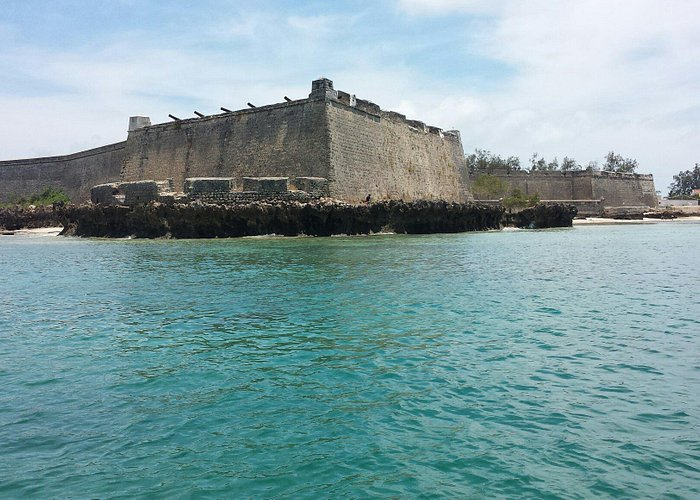What do you see happening in this image? The image showcases the majestic Fort of São Sebastião on Mozambique Island. This grand stone fortress, with its rectangular structure and flat roof, tells a story of a time long past. Perched at the island's edge, it offers a stunning view over the serene turquoise waters of the ocean. Above, the sky is a clear blue with a sprinkling of fluffy clouds, adding to the peaceful panorama. Despite its grandeur, the fort bears the marks of history; its stone walls show signs of deterioration, with some sections crumbling and parts of the roof missing. This blend of historical architecture and natural beauty provides a captivating glimpse into the rich heritage of this iconic landmark. 